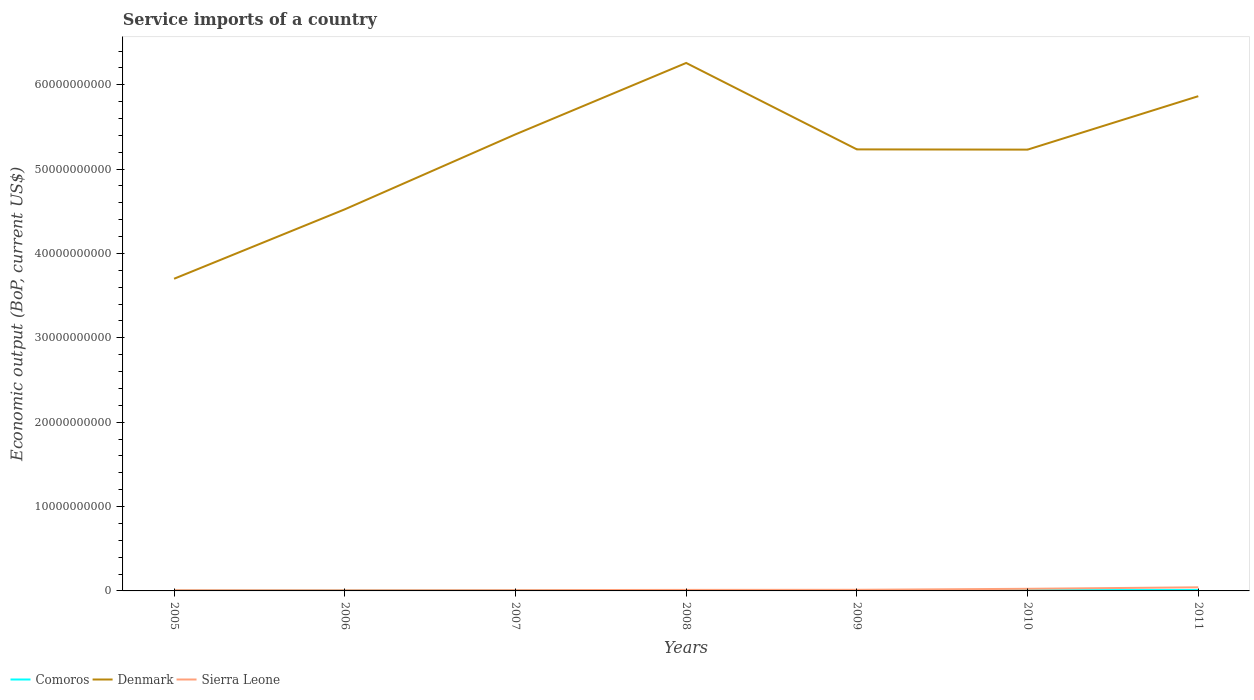Is the number of lines equal to the number of legend labels?
Your answer should be very brief. Yes. Across all years, what is the maximum service imports in Denmark?
Provide a succinct answer. 3.70e+1. In which year was the service imports in Denmark maximum?
Give a very brief answer. 2005. What is the total service imports in Comoros in the graph?
Keep it short and to the point. -1.35e+07. What is the difference between the highest and the second highest service imports in Denmark?
Provide a short and direct response. 2.56e+1. What is the difference between the highest and the lowest service imports in Comoros?
Offer a terse response. 4. Is the service imports in Sierra Leone strictly greater than the service imports in Denmark over the years?
Your answer should be compact. Yes. How many years are there in the graph?
Provide a short and direct response. 7. What is the difference between two consecutive major ticks on the Y-axis?
Your response must be concise. 1.00e+1. Does the graph contain any zero values?
Your response must be concise. No. Does the graph contain grids?
Give a very brief answer. No. Where does the legend appear in the graph?
Your answer should be very brief. Bottom left. How many legend labels are there?
Offer a terse response. 3. What is the title of the graph?
Keep it short and to the point. Service imports of a country. What is the label or title of the Y-axis?
Offer a terse response. Economic output (BoP, current US$). What is the Economic output (BoP, current US$) in Comoros in 2005?
Make the answer very short. 4.58e+07. What is the Economic output (BoP, current US$) in Denmark in 2005?
Your answer should be very brief. 3.70e+1. What is the Economic output (BoP, current US$) in Sierra Leone in 2005?
Keep it short and to the point. 9.14e+07. What is the Economic output (BoP, current US$) in Comoros in 2006?
Provide a short and direct response. 5.49e+07. What is the Economic output (BoP, current US$) in Denmark in 2006?
Keep it short and to the point. 4.52e+1. What is the Economic output (BoP, current US$) of Sierra Leone in 2006?
Offer a terse response. 8.40e+07. What is the Economic output (BoP, current US$) of Comoros in 2007?
Ensure brevity in your answer.  6.35e+07. What is the Economic output (BoP, current US$) in Denmark in 2007?
Keep it short and to the point. 5.41e+1. What is the Economic output (BoP, current US$) in Sierra Leone in 2007?
Your response must be concise. 9.43e+07. What is the Economic output (BoP, current US$) in Comoros in 2008?
Provide a short and direct response. 7.94e+07. What is the Economic output (BoP, current US$) of Denmark in 2008?
Ensure brevity in your answer.  6.26e+1. What is the Economic output (BoP, current US$) of Sierra Leone in 2008?
Your answer should be compact. 1.21e+08. What is the Economic output (BoP, current US$) of Comoros in 2009?
Offer a terse response. 8.40e+07. What is the Economic output (BoP, current US$) of Denmark in 2009?
Offer a terse response. 5.23e+1. What is the Economic output (BoP, current US$) of Sierra Leone in 2009?
Your answer should be very brief. 1.32e+08. What is the Economic output (BoP, current US$) of Comoros in 2010?
Keep it short and to the point. 9.40e+07. What is the Economic output (BoP, current US$) of Denmark in 2010?
Offer a terse response. 5.23e+1. What is the Economic output (BoP, current US$) in Sierra Leone in 2010?
Ensure brevity in your answer.  2.52e+08. What is the Economic output (BoP, current US$) of Comoros in 2011?
Your answer should be compact. 1.08e+08. What is the Economic output (BoP, current US$) in Denmark in 2011?
Make the answer very short. 5.86e+1. What is the Economic output (BoP, current US$) in Sierra Leone in 2011?
Keep it short and to the point. 4.28e+08. Across all years, what is the maximum Economic output (BoP, current US$) of Comoros?
Provide a short and direct response. 1.08e+08. Across all years, what is the maximum Economic output (BoP, current US$) in Denmark?
Offer a terse response. 6.26e+1. Across all years, what is the maximum Economic output (BoP, current US$) of Sierra Leone?
Offer a terse response. 4.28e+08. Across all years, what is the minimum Economic output (BoP, current US$) of Comoros?
Offer a very short reply. 4.58e+07. Across all years, what is the minimum Economic output (BoP, current US$) of Denmark?
Provide a succinct answer. 3.70e+1. Across all years, what is the minimum Economic output (BoP, current US$) in Sierra Leone?
Make the answer very short. 8.40e+07. What is the total Economic output (BoP, current US$) of Comoros in the graph?
Give a very brief answer. 5.29e+08. What is the total Economic output (BoP, current US$) of Denmark in the graph?
Your answer should be compact. 3.62e+11. What is the total Economic output (BoP, current US$) of Sierra Leone in the graph?
Your answer should be very brief. 1.20e+09. What is the difference between the Economic output (BoP, current US$) in Comoros in 2005 and that in 2006?
Keep it short and to the point. -9.10e+06. What is the difference between the Economic output (BoP, current US$) in Denmark in 2005 and that in 2006?
Your answer should be very brief. -8.23e+09. What is the difference between the Economic output (BoP, current US$) of Sierra Leone in 2005 and that in 2006?
Give a very brief answer. 7.37e+06. What is the difference between the Economic output (BoP, current US$) in Comoros in 2005 and that in 2007?
Offer a terse response. -1.76e+07. What is the difference between the Economic output (BoP, current US$) in Denmark in 2005 and that in 2007?
Make the answer very short. -1.71e+1. What is the difference between the Economic output (BoP, current US$) in Sierra Leone in 2005 and that in 2007?
Provide a short and direct response. -2.94e+06. What is the difference between the Economic output (BoP, current US$) of Comoros in 2005 and that in 2008?
Give a very brief answer. -3.36e+07. What is the difference between the Economic output (BoP, current US$) of Denmark in 2005 and that in 2008?
Give a very brief answer. -2.56e+1. What is the difference between the Economic output (BoP, current US$) in Sierra Leone in 2005 and that in 2008?
Your answer should be very brief. -2.96e+07. What is the difference between the Economic output (BoP, current US$) in Comoros in 2005 and that in 2009?
Ensure brevity in your answer.  -3.82e+07. What is the difference between the Economic output (BoP, current US$) of Denmark in 2005 and that in 2009?
Provide a short and direct response. -1.53e+1. What is the difference between the Economic output (BoP, current US$) in Sierra Leone in 2005 and that in 2009?
Provide a short and direct response. -4.07e+07. What is the difference between the Economic output (BoP, current US$) of Comoros in 2005 and that in 2010?
Ensure brevity in your answer.  -4.82e+07. What is the difference between the Economic output (BoP, current US$) in Denmark in 2005 and that in 2010?
Provide a short and direct response. -1.53e+1. What is the difference between the Economic output (BoP, current US$) of Sierra Leone in 2005 and that in 2010?
Your response must be concise. -1.60e+08. What is the difference between the Economic output (BoP, current US$) of Comoros in 2005 and that in 2011?
Your response must be concise. -6.17e+07. What is the difference between the Economic output (BoP, current US$) of Denmark in 2005 and that in 2011?
Keep it short and to the point. -2.16e+1. What is the difference between the Economic output (BoP, current US$) in Sierra Leone in 2005 and that in 2011?
Provide a short and direct response. -3.36e+08. What is the difference between the Economic output (BoP, current US$) of Comoros in 2006 and that in 2007?
Offer a terse response. -8.55e+06. What is the difference between the Economic output (BoP, current US$) in Denmark in 2006 and that in 2007?
Make the answer very short. -8.89e+09. What is the difference between the Economic output (BoP, current US$) of Sierra Leone in 2006 and that in 2007?
Keep it short and to the point. -1.03e+07. What is the difference between the Economic output (BoP, current US$) of Comoros in 2006 and that in 2008?
Your response must be concise. -2.45e+07. What is the difference between the Economic output (BoP, current US$) in Denmark in 2006 and that in 2008?
Your answer should be very brief. -1.74e+1. What is the difference between the Economic output (BoP, current US$) of Sierra Leone in 2006 and that in 2008?
Give a very brief answer. -3.70e+07. What is the difference between the Economic output (BoP, current US$) in Comoros in 2006 and that in 2009?
Offer a very short reply. -2.91e+07. What is the difference between the Economic output (BoP, current US$) in Denmark in 2006 and that in 2009?
Your answer should be very brief. -7.11e+09. What is the difference between the Economic output (BoP, current US$) of Sierra Leone in 2006 and that in 2009?
Your answer should be compact. -4.81e+07. What is the difference between the Economic output (BoP, current US$) of Comoros in 2006 and that in 2010?
Make the answer very short. -3.91e+07. What is the difference between the Economic output (BoP, current US$) of Denmark in 2006 and that in 2010?
Ensure brevity in your answer.  -7.08e+09. What is the difference between the Economic output (BoP, current US$) in Sierra Leone in 2006 and that in 2010?
Provide a short and direct response. -1.68e+08. What is the difference between the Economic output (BoP, current US$) of Comoros in 2006 and that in 2011?
Give a very brief answer. -5.26e+07. What is the difference between the Economic output (BoP, current US$) of Denmark in 2006 and that in 2011?
Give a very brief answer. -1.34e+1. What is the difference between the Economic output (BoP, current US$) of Sierra Leone in 2006 and that in 2011?
Your response must be concise. -3.44e+08. What is the difference between the Economic output (BoP, current US$) in Comoros in 2007 and that in 2008?
Your answer should be very brief. -1.60e+07. What is the difference between the Economic output (BoP, current US$) of Denmark in 2007 and that in 2008?
Your answer should be compact. -8.46e+09. What is the difference between the Economic output (BoP, current US$) of Sierra Leone in 2007 and that in 2008?
Offer a terse response. -2.66e+07. What is the difference between the Economic output (BoP, current US$) of Comoros in 2007 and that in 2009?
Your response must be concise. -2.06e+07. What is the difference between the Economic output (BoP, current US$) in Denmark in 2007 and that in 2009?
Your answer should be compact. 1.78e+09. What is the difference between the Economic output (BoP, current US$) in Sierra Leone in 2007 and that in 2009?
Offer a very short reply. -3.78e+07. What is the difference between the Economic output (BoP, current US$) in Comoros in 2007 and that in 2010?
Your answer should be very brief. -3.05e+07. What is the difference between the Economic output (BoP, current US$) of Denmark in 2007 and that in 2010?
Offer a terse response. 1.81e+09. What is the difference between the Economic output (BoP, current US$) in Sierra Leone in 2007 and that in 2010?
Your response must be concise. -1.57e+08. What is the difference between the Economic output (BoP, current US$) of Comoros in 2007 and that in 2011?
Provide a succinct answer. -4.40e+07. What is the difference between the Economic output (BoP, current US$) of Denmark in 2007 and that in 2011?
Provide a succinct answer. -4.52e+09. What is the difference between the Economic output (BoP, current US$) of Sierra Leone in 2007 and that in 2011?
Keep it short and to the point. -3.33e+08. What is the difference between the Economic output (BoP, current US$) of Comoros in 2008 and that in 2009?
Your answer should be compact. -4.60e+06. What is the difference between the Economic output (BoP, current US$) of Denmark in 2008 and that in 2009?
Offer a terse response. 1.02e+1. What is the difference between the Economic output (BoP, current US$) in Sierra Leone in 2008 and that in 2009?
Give a very brief answer. -1.11e+07. What is the difference between the Economic output (BoP, current US$) in Comoros in 2008 and that in 2010?
Your answer should be very brief. -1.45e+07. What is the difference between the Economic output (BoP, current US$) of Denmark in 2008 and that in 2010?
Your answer should be very brief. 1.03e+1. What is the difference between the Economic output (BoP, current US$) in Sierra Leone in 2008 and that in 2010?
Ensure brevity in your answer.  -1.31e+08. What is the difference between the Economic output (BoP, current US$) in Comoros in 2008 and that in 2011?
Ensure brevity in your answer.  -2.81e+07. What is the difference between the Economic output (BoP, current US$) in Denmark in 2008 and that in 2011?
Provide a succinct answer. 3.94e+09. What is the difference between the Economic output (BoP, current US$) of Sierra Leone in 2008 and that in 2011?
Make the answer very short. -3.07e+08. What is the difference between the Economic output (BoP, current US$) of Comoros in 2009 and that in 2010?
Give a very brief answer. -9.95e+06. What is the difference between the Economic output (BoP, current US$) of Denmark in 2009 and that in 2010?
Give a very brief answer. 2.79e+07. What is the difference between the Economic output (BoP, current US$) in Sierra Leone in 2009 and that in 2010?
Make the answer very short. -1.20e+08. What is the difference between the Economic output (BoP, current US$) in Comoros in 2009 and that in 2011?
Provide a succinct answer. -2.35e+07. What is the difference between the Economic output (BoP, current US$) in Denmark in 2009 and that in 2011?
Make the answer very short. -6.30e+09. What is the difference between the Economic output (BoP, current US$) in Sierra Leone in 2009 and that in 2011?
Provide a succinct answer. -2.96e+08. What is the difference between the Economic output (BoP, current US$) in Comoros in 2010 and that in 2011?
Your answer should be compact. -1.35e+07. What is the difference between the Economic output (BoP, current US$) in Denmark in 2010 and that in 2011?
Keep it short and to the point. -6.33e+09. What is the difference between the Economic output (BoP, current US$) of Sierra Leone in 2010 and that in 2011?
Your response must be concise. -1.76e+08. What is the difference between the Economic output (BoP, current US$) of Comoros in 2005 and the Economic output (BoP, current US$) of Denmark in 2006?
Provide a short and direct response. -4.52e+1. What is the difference between the Economic output (BoP, current US$) of Comoros in 2005 and the Economic output (BoP, current US$) of Sierra Leone in 2006?
Keep it short and to the point. -3.82e+07. What is the difference between the Economic output (BoP, current US$) of Denmark in 2005 and the Economic output (BoP, current US$) of Sierra Leone in 2006?
Keep it short and to the point. 3.69e+1. What is the difference between the Economic output (BoP, current US$) of Comoros in 2005 and the Economic output (BoP, current US$) of Denmark in 2007?
Ensure brevity in your answer.  -5.41e+1. What is the difference between the Economic output (BoP, current US$) of Comoros in 2005 and the Economic output (BoP, current US$) of Sierra Leone in 2007?
Offer a very short reply. -4.85e+07. What is the difference between the Economic output (BoP, current US$) of Denmark in 2005 and the Economic output (BoP, current US$) of Sierra Leone in 2007?
Your answer should be compact. 3.69e+1. What is the difference between the Economic output (BoP, current US$) in Comoros in 2005 and the Economic output (BoP, current US$) in Denmark in 2008?
Offer a very short reply. -6.25e+1. What is the difference between the Economic output (BoP, current US$) of Comoros in 2005 and the Economic output (BoP, current US$) of Sierra Leone in 2008?
Offer a terse response. -7.51e+07. What is the difference between the Economic output (BoP, current US$) of Denmark in 2005 and the Economic output (BoP, current US$) of Sierra Leone in 2008?
Offer a terse response. 3.69e+1. What is the difference between the Economic output (BoP, current US$) of Comoros in 2005 and the Economic output (BoP, current US$) of Denmark in 2009?
Keep it short and to the point. -5.23e+1. What is the difference between the Economic output (BoP, current US$) of Comoros in 2005 and the Economic output (BoP, current US$) of Sierra Leone in 2009?
Offer a terse response. -8.63e+07. What is the difference between the Economic output (BoP, current US$) of Denmark in 2005 and the Economic output (BoP, current US$) of Sierra Leone in 2009?
Give a very brief answer. 3.69e+1. What is the difference between the Economic output (BoP, current US$) of Comoros in 2005 and the Economic output (BoP, current US$) of Denmark in 2010?
Ensure brevity in your answer.  -5.23e+1. What is the difference between the Economic output (BoP, current US$) in Comoros in 2005 and the Economic output (BoP, current US$) in Sierra Leone in 2010?
Make the answer very short. -2.06e+08. What is the difference between the Economic output (BoP, current US$) of Denmark in 2005 and the Economic output (BoP, current US$) of Sierra Leone in 2010?
Offer a terse response. 3.68e+1. What is the difference between the Economic output (BoP, current US$) of Comoros in 2005 and the Economic output (BoP, current US$) of Denmark in 2011?
Your answer should be very brief. -5.86e+1. What is the difference between the Economic output (BoP, current US$) in Comoros in 2005 and the Economic output (BoP, current US$) in Sierra Leone in 2011?
Give a very brief answer. -3.82e+08. What is the difference between the Economic output (BoP, current US$) of Denmark in 2005 and the Economic output (BoP, current US$) of Sierra Leone in 2011?
Keep it short and to the point. 3.66e+1. What is the difference between the Economic output (BoP, current US$) in Comoros in 2006 and the Economic output (BoP, current US$) in Denmark in 2007?
Provide a short and direct response. -5.41e+1. What is the difference between the Economic output (BoP, current US$) of Comoros in 2006 and the Economic output (BoP, current US$) of Sierra Leone in 2007?
Your answer should be very brief. -3.94e+07. What is the difference between the Economic output (BoP, current US$) in Denmark in 2006 and the Economic output (BoP, current US$) in Sierra Leone in 2007?
Provide a short and direct response. 4.51e+1. What is the difference between the Economic output (BoP, current US$) of Comoros in 2006 and the Economic output (BoP, current US$) of Denmark in 2008?
Provide a succinct answer. -6.25e+1. What is the difference between the Economic output (BoP, current US$) of Comoros in 2006 and the Economic output (BoP, current US$) of Sierra Leone in 2008?
Keep it short and to the point. -6.60e+07. What is the difference between the Economic output (BoP, current US$) of Denmark in 2006 and the Economic output (BoP, current US$) of Sierra Leone in 2008?
Keep it short and to the point. 4.51e+1. What is the difference between the Economic output (BoP, current US$) of Comoros in 2006 and the Economic output (BoP, current US$) of Denmark in 2009?
Give a very brief answer. -5.23e+1. What is the difference between the Economic output (BoP, current US$) in Comoros in 2006 and the Economic output (BoP, current US$) in Sierra Leone in 2009?
Provide a short and direct response. -7.72e+07. What is the difference between the Economic output (BoP, current US$) of Denmark in 2006 and the Economic output (BoP, current US$) of Sierra Leone in 2009?
Your answer should be compact. 4.51e+1. What is the difference between the Economic output (BoP, current US$) of Comoros in 2006 and the Economic output (BoP, current US$) of Denmark in 2010?
Provide a short and direct response. -5.23e+1. What is the difference between the Economic output (BoP, current US$) of Comoros in 2006 and the Economic output (BoP, current US$) of Sierra Leone in 2010?
Ensure brevity in your answer.  -1.97e+08. What is the difference between the Economic output (BoP, current US$) of Denmark in 2006 and the Economic output (BoP, current US$) of Sierra Leone in 2010?
Offer a very short reply. 4.50e+1. What is the difference between the Economic output (BoP, current US$) of Comoros in 2006 and the Economic output (BoP, current US$) of Denmark in 2011?
Keep it short and to the point. -5.86e+1. What is the difference between the Economic output (BoP, current US$) in Comoros in 2006 and the Economic output (BoP, current US$) in Sierra Leone in 2011?
Your answer should be very brief. -3.73e+08. What is the difference between the Economic output (BoP, current US$) of Denmark in 2006 and the Economic output (BoP, current US$) of Sierra Leone in 2011?
Ensure brevity in your answer.  4.48e+1. What is the difference between the Economic output (BoP, current US$) of Comoros in 2007 and the Economic output (BoP, current US$) of Denmark in 2008?
Ensure brevity in your answer.  -6.25e+1. What is the difference between the Economic output (BoP, current US$) in Comoros in 2007 and the Economic output (BoP, current US$) in Sierra Leone in 2008?
Your answer should be compact. -5.75e+07. What is the difference between the Economic output (BoP, current US$) in Denmark in 2007 and the Economic output (BoP, current US$) in Sierra Leone in 2008?
Your answer should be very brief. 5.40e+1. What is the difference between the Economic output (BoP, current US$) in Comoros in 2007 and the Economic output (BoP, current US$) in Denmark in 2009?
Keep it short and to the point. -5.23e+1. What is the difference between the Economic output (BoP, current US$) in Comoros in 2007 and the Economic output (BoP, current US$) in Sierra Leone in 2009?
Provide a short and direct response. -6.86e+07. What is the difference between the Economic output (BoP, current US$) in Denmark in 2007 and the Economic output (BoP, current US$) in Sierra Leone in 2009?
Your answer should be compact. 5.40e+1. What is the difference between the Economic output (BoP, current US$) in Comoros in 2007 and the Economic output (BoP, current US$) in Denmark in 2010?
Keep it short and to the point. -5.22e+1. What is the difference between the Economic output (BoP, current US$) of Comoros in 2007 and the Economic output (BoP, current US$) of Sierra Leone in 2010?
Keep it short and to the point. -1.88e+08. What is the difference between the Economic output (BoP, current US$) in Denmark in 2007 and the Economic output (BoP, current US$) in Sierra Leone in 2010?
Keep it short and to the point. 5.39e+1. What is the difference between the Economic output (BoP, current US$) of Comoros in 2007 and the Economic output (BoP, current US$) of Denmark in 2011?
Give a very brief answer. -5.86e+1. What is the difference between the Economic output (BoP, current US$) of Comoros in 2007 and the Economic output (BoP, current US$) of Sierra Leone in 2011?
Ensure brevity in your answer.  -3.64e+08. What is the difference between the Economic output (BoP, current US$) of Denmark in 2007 and the Economic output (BoP, current US$) of Sierra Leone in 2011?
Your answer should be very brief. 5.37e+1. What is the difference between the Economic output (BoP, current US$) in Comoros in 2008 and the Economic output (BoP, current US$) in Denmark in 2009?
Offer a terse response. -5.23e+1. What is the difference between the Economic output (BoP, current US$) in Comoros in 2008 and the Economic output (BoP, current US$) in Sierra Leone in 2009?
Ensure brevity in your answer.  -5.27e+07. What is the difference between the Economic output (BoP, current US$) in Denmark in 2008 and the Economic output (BoP, current US$) in Sierra Leone in 2009?
Your response must be concise. 6.25e+1. What is the difference between the Economic output (BoP, current US$) of Comoros in 2008 and the Economic output (BoP, current US$) of Denmark in 2010?
Your answer should be compact. -5.22e+1. What is the difference between the Economic output (BoP, current US$) in Comoros in 2008 and the Economic output (BoP, current US$) in Sierra Leone in 2010?
Provide a succinct answer. -1.72e+08. What is the difference between the Economic output (BoP, current US$) of Denmark in 2008 and the Economic output (BoP, current US$) of Sierra Leone in 2010?
Keep it short and to the point. 6.23e+1. What is the difference between the Economic output (BoP, current US$) of Comoros in 2008 and the Economic output (BoP, current US$) of Denmark in 2011?
Make the answer very short. -5.86e+1. What is the difference between the Economic output (BoP, current US$) of Comoros in 2008 and the Economic output (BoP, current US$) of Sierra Leone in 2011?
Offer a terse response. -3.48e+08. What is the difference between the Economic output (BoP, current US$) in Denmark in 2008 and the Economic output (BoP, current US$) in Sierra Leone in 2011?
Your response must be concise. 6.22e+1. What is the difference between the Economic output (BoP, current US$) of Comoros in 2009 and the Economic output (BoP, current US$) of Denmark in 2010?
Offer a very short reply. -5.22e+1. What is the difference between the Economic output (BoP, current US$) of Comoros in 2009 and the Economic output (BoP, current US$) of Sierra Leone in 2010?
Your answer should be very brief. -1.68e+08. What is the difference between the Economic output (BoP, current US$) of Denmark in 2009 and the Economic output (BoP, current US$) of Sierra Leone in 2010?
Your response must be concise. 5.21e+1. What is the difference between the Economic output (BoP, current US$) of Comoros in 2009 and the Economic output (BoP, current US$) of Denmark in 2011?
Keep it short and to the point. -5.86e+1. What is the difference between the Economic output (BoP, current US$) in Comoros in 2009 and the Economic output (BoP, current US$) in Sierra Leone in 2011?
Keep it short and to the point. -3.44e+08. What is the difference between the Economic output (BoP, current US$) of Denmark in 2009 and the Economic output (BoP, current US$) of Sierra Leone in 2011?
Your response must be concise. 5.19e+1. What is the difference between the Economic output (BoP, current US$) of Comoros in 2010 and the Economic output (BoP, current US$) of Denmark in 2011?
Offer a terse response. -5.85e+1. What is the difference between the Economic output (BoP, current US$) in Comoros in 2010 and the Economic output (BoP, current US$) in Sierra Leone in 2011?
Offer a very short reply. -3.34e+08. What is the difference between the Economic output (BoP, current US$) in Denmark in 2010 and the Economic output (BoP, current US$) in Sierra Leone in 2011?
Your answer should be very brief. 5.19e+1. What is the average Economic output (BoP, current US$) in Comoros per year?
Offer a very short reply. 7.56e+07. What is the average Economic output (BoP, current US$) of Denmark per year?
Your response must be concise. 5.17e+1. What is the average Economic output (BoP, current US$) in Sierra Leone per year?
Offer a terse response. 1.72e+08. In the year 2005, what is the difference between the Economic output (BoP, current US$) in Comoros and Economic output (BoP, current US$) in Denmark?
Your response must be concise. -3.70e+1. In the year 2005, what is the difference between the Economic output (BoP, current US$) of Comoros and Economic output (BoP, current US$) of Sierra Leone?
Your response must be concise. -4.55e+07. In the year 2005, what is the difference between the Economic output (BoP, current US$) of Denmark and Economic output (BoP, current US$) of Sierra Leone?
Provide a short and direct response. 3.69e+1. In the year 2006, what is the difference between the Economic output (BoP, current US$) in Comoros and Economic output (BoP, current US$) in Denmark?
Your answer should be compact. -4.52e+1. In the year 2006, what is the difference between the Economic output (BoP, current US$) in Comoros and Economic output (BoP, current US$) in Sierra Leone?
Make the answer very short. -2.91e+07. In the year 2006, what is the difference between the Economic output (BoP, current US$) in Denmark and Economic output (BoP, current US$) in Sierra Leone?
Provide a short and direct response. 4.51e+1. In the year 2007, what is the difference between the Economic output (BoP, current US$) of Comoros and Economic output (BoP, current US$) of Denmark?
Your response must be concise. -5.41e+1. In the year 2007, what is the difference between the Economic output (BoP, current US$) in Comoros and Economic output (BoP, current US$) in Sierra Leone?
Offer a terse response. -3.08e+07. In the year 2007, what is the difference between the Economic output (BoP, current US$) in Denmark and Economic output (BoP, current US$) in Sierra Leone?
Keep it short and to the point. 5.40e+1. In the year 2008, what is the difference between the Economic output (BoP, current US$) in Comoros and Economic output (BoP, current US$) in Denmark?
Offer a terse response. -6.25e+1. In the year 2008, what is the difference between the Economic output (BoP, current US$) in Comoros and Economic output (BoP, current US$) in Sierra Leone?
Give a very brief answer. -4.15e+07. In the year 2008, what is the difference between the Economic output (BoP, current US$) in Denmark and Economic output (BoP, current US$) in Sierra Leone?
Your answer should be compact. 6.25e+1. In the year 2009, what is the difference between the Economic output (BoP, current US$) of Comoros and Economic output (BoP, current US$) of Denmark?
Keep it short and to the point. -5.23e+1. In the year 2009, what is the difference between the Economic output (BoP, current US$) in Comoros and Economic output (BoP, current US$) in Sierra Leone?
Give a very brief answer. -4.81e+07. In the year 2009, what is the difference between the Economic output (BoP, current US$) in Denmark and Economic output (BoP, current US$) in Sierra Leone?
Your answer should be very brief. 5.22e+1. In the year 2010, what is the difference between the Economic output (BoP, current US$) in Comoros and Economic output (BoP, current US$) in Denmark?
Give a very brief answer. -5.22e+1. In the year 2010, what is the difference between the Economic output (BoP, current US$) in Comoros and Economic output (BoP, current US$) in Sierra Leone?
Offer a terse response. -1.58e+08. In the year 2010, what is the difference between the Economic output (BoP, current US$) of Denmark and Economic output (BoP, current US$) of Sierra Leone?
Ensure brevity in your answer.  5.21e+1. In the year 2011, what is the difference between the Economic output (BoP, current US$) of Comoros and Economic output (BoP, current US$) of Denmark?
Make the answer very short. -5.85e+1. In the year 2011, what is the difference between the Economic output (BoP, current US$) in Comoros and Economic output (BoP, current US$) in Sierra Leone?
Make the answer very short. -3.20e+08. In the year 2011, what is the difference between the Economic output (BoP, current US$) of Denmark and Economic output (BoP, current US$) of Sierra Leone?
Your answer should be very brief. 5.82e+1. What is the ratio of the Economic output (BoP, current US$) in Comoros in 2005 to that in 2006?
Your response must be concise. 0.83. What is the ratio of the Economic output (BoP, current US$) in Denmark in 2005 to that in 2006?
Offer a terse response. 0.82. What is the ratio of the Economic output (BoP, current US$) in Sierra Leone in 2005 to that in 2006?
Keep it short and to the point. 1.09. What is the ratio of the Economic output (BoP, current US$) of Comoros in 2005 to that in 2007?
Provide a short and direct response. 0.72. What is the ratio of the Economic output (BoP, current US$) of Denmark in 2005 to that in 2007?
Your response must be concise. 0.68. What is the ratio of the Economic output (BoP, current US$) in Sierra Leone in 2005 to that in 2007?
Give a very brief answer. 0.97. What is the ratio of the Economic output (BoP, current US$) of Comoros in 2005 to that in 2008?
Make the answer very short. 0.58. What is the ratio of the Economic output (BoP, current US$) in Denmark in 2005 to that in 2008?
Offer a very short reply. 0.59. What is the ratio of the Economic output (BoP, current US$) of Sierra Leone in 2005 to that in 2008?
Provide a succinct answer. 0.76. What is the ratio of the Economic output (BoP, current US$) in Comoros in 2005 to that in 2009?
Your response must be concise. 0.55. What is the ratio of the Economic output (BoP, current US$) in Denmark in 2005 to that in 2009?
Keep it short and to the point. 0.71. What is the ratio of the Economic output (BoP, current US$) in Sierra Leone in 2005 to that in 2009?
Your response must be concise. 0.69. What is the ratio of the Economic output (BoP, current US$) of Comoros in 2005 to that in 2010?
Offer a very short reply. 0.49. What is the ratio of the Economic output (BoP, current US$) in Denmark in 2005 to that in 2010?
Your answer should be compact. 0.71. What is the ratio of the Economic output (BoP, current US$) in Sierra Leone in 2005 to that in 2010?
Make the answer very short. 0.36. What is the ratio of the Economic output (BoP, current US$) of Comoros in 2005 to that in 2011?
Offer a very short reply. 0.43. What is the ratio of the Economic output (BoP, current US$) in Denmark in 2005 to that in 2011?
Make the answer very short. 0.63. What is the ratio of the Economic output (BoP, current US$) in Sierra Leone in 2005 to that in 2011?
Your answer should be very brief. 0.21. What is the ratio of the Economic output (BoP, current US$) in Comoros in 2006 to that in 2007?
Your response must be concise. 0.87. What is the ratio of the Economic output (BoP, current US$) of Denmark in 2006 to that in 2007?
Offer a very short reply. 0.84. What is the ratio of the Economic output (BoP, current US$) of Sierra Leone in 2006 to that in 2007?
Your answer should be very brief. 0.89. What is the ratio of the Economic output (BoP, current US$) of Comoros in 2006 to that in 2008?
Give a very brief answer. 0.69. What is the ratio of the Economic output (BoP, current US$) of Denmark in 2006 to that in 2008?
Keep it short and to the point. 0.72. What is the ratio of the Economic output (BoP, current US$) of Sierra Leone in 2006 to that in 2008?
Your answer should be very brief. 0.69. What is the ratio of the Economic output (BoP, current US$) of Comoros in 2006 to that in 2009?
Your response must be concise. 0.65. What is the ratio of the Economic output (BoP, current US$) of Denmark in 2006 to that in 2009?
Offer a very short reply. 0.86. What is the ratio of the Economic output (BoP, current US$) in Sierra Leone in 2006 to that in 2009?
Provide a succinct answer. 0.64. What is the ratio of the Economic output (BoP, current US$) in Comoros in 2006 to that in 2010?
Provide a short and direct response. 0.58. What is the ratio of the Economic output (BoP, current US$) in Denmark in 2006 to that in 2010?
Provide a succinct answer. 0.86. What is the ratio of the Economic output (BoP, current US$) of Sierra Leone in 2006 to that in 2010?
Provide a succinct answer. 0.33. What is the ratio of the Economic output (BoP, current US$) in Comoros in 2006 to that in 2011?
Your response must be concise. 0.51. What is the ratio of the Economic output (BoP, current US$) of Denmark in 2006 to that in 2011?
Your answer should be very brief. 0.77. What is the ratio of the Economic output (BoP, current US$) in Sierra Leone in 2006 to that in 2011?
Provide a succinct answer. 0.2. What is the ratio of the Economic output (BoP, current US$) in Comoros in 2007 to that in 2008?
Offer a very short reply. 0.8. What is the ratio of the Economic output (BoP, current US$) of Denmark in 2007 to that in 2008?
Provide a short and direct response. 0.86. What is the ratio of the Economic output (BoP, current US$) of Sierra Leone in 2007 to that in 2008?
Your response must be concise. 0.78. What is the ratio of the Economic output (BoP, current US$) in Comoros in 2007 to that in 2009?
Your answer should be very brief. 0.76. What is the ratio of the Economic output (BoP, current US$) of Denmark in 2007 to that in 2009?
Make the answer very short. 1.03. What is the ratio of the Economic output (BoP, current US$) in Sierra Leone in 2007 to that in 2009?
Your response must be concise. 0.71. What is the ratio of the Economic output (BoP, current US$) of Comoros in 2007 to that in 2010?
Ensure brevity in your answer.  0.68. What is the ratio of the Economic output (BoP, current US$) in Denmark in 2007 to that in 2010?
Offer a very short reply. 1.03. What is the ratio of the Economic output (BoP, current US$) in Sierra Leone in 2007 to that in 2010?
Ensure brevity in your answer.  0.37. What is the ratio of the Economic output (BoP, current US$) of Comoros in 2007 to that in 2011?
Provide a succinct answer. 0.59. What is the ratio of the Economic output (BoP, current US$) of Denmark in 2007 to that in 2011?
Offer a very short reply. 0.92. What is the ratio of the Economic output (BoP, current US$) of Sierra Leone in 2007 to that in 2011?
Your answer should be very brief. 0.22. What is the ratio of the Economic output (BoP, current US$) of Comoros in 2008 to that in 2009?
Provide a succinct answer. 0.95. What is the ratio of the Economic output (BoP, current US$) of Denmark in 2008 to that in 2009?
Give a very brief answer. 1.2. What is the ratio of the Economic output (BoP, current US$) in Sierra Leone in 2008 to that in 2009?
Give a very brief answer. 0.92. What is the ratio of the Economic output (BoP, current US$) in Comoros in 2008 to that in 2010?
Offer a very short reply. 0.85. What is the ratio of the Economic output (BoP, current US$) of Denmark in 2008 to that in 2010?
Keep it short and to the point. 1.2. What is the ratio of the Economic output (BoP, current US$) of Sierra Leone in 2008 to that in 2010?
Your response must be concise. 0.48. What is the ratio of the Economic output (BoP, current US$) in Comoros in 2008 to that in 2011?
Keep it short and to the point. 0.74. What is the ratio of the Economic output (BoP, current US$) of Denmark in 2008 to that in 2011?
Make the answer very short. 1.07. What is the ratio of the Economic output (BoP, current US$) in Sierra Leone in 2008 to that in 2011?
Offer a very short reply. 0.28. What is the ratio of the Economic output (BoP, current US$) in Comoros in 2009 to that in 2010?
Provide a short and direct response. 0.89. What is the ratio of the Economic output (BoP, current US$) of Denmark in 2009 to that in 2010?
Keep it short and to the point. 1. What is the ratio of the Economic output (BoP, current US$) of Sierra Leone in 2009 to that in 2010?
Make the answer very short. 0.53. What is the ratio of the Economic output (BoP, current US$) in Comoros in 2009 to that in 2011?
Keep it short and to the point. 0.78. What is the ratio of the Economic output (BoP, current US$) of Denmark in 2009 to that in 2011?
Offer a very short reply. 0.89. What is the ratio of the Economic output (BoP, current US$) of Sierra Leone in 2009 to that in 2011?
Keep it short and to the point. 0.31. What is the ratio of the Economic output (BoP, current US$) in Comoros in 2010 to that in 2011?
Your response must be concise. 0.87. What is the ratio of the Economic output (BoP, current US$) in Denmark in 2010 to that in 2011?
Offer a terse response. 0.89. What is the ratio of the Economic output (BoP, current US$) of Sierra Leone in 2010 to that in 2011?
Provide a succinct answer. 0.59. What is the difference between the highest and the second highest Economic output (BoP, current US$) of Comoros?
Keep it short and to the point. 1.35e+07. What is the difference between the highest and the second highest Economic output (BoP, current US$) of Denmark?
Your answer should be very brief. 3.94e+09. What is the difference between the highest and the second highest Economic output (BoP, current US$) in Sierra Leone?
Your answer should be very brief. 1.76e+08. What is the difference between the highest and the lowest Economic output (BoP, current US$) of Comoros?
Keep it short and to the point. 6.17e+07. What is the difference between the highest and the lowest Economic output (BoP, current US$) in Denmark?
Make the answer very short. 2.56e+1. What is the difference between the highest and the lowest Economic output (BoP, current US$) in Sierra Leone?
Ensure brevity in your answer.  3.44e+08. 